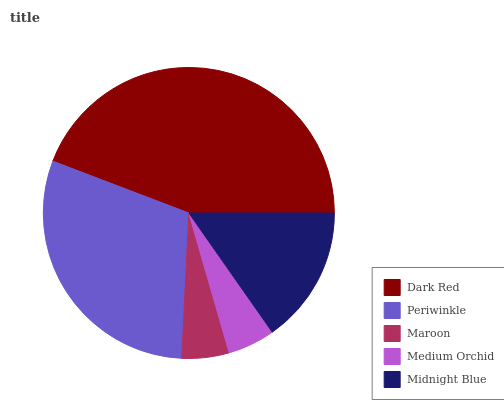Is Maroon the minimum?
Answer yes or no. Yes. Is Dark Red the maximum?
Answer yes or no. Yes. Is Periwinkle the minimum?
Answer yes or no. No. Is Periwinkle the maximum?
Answer yes or no. No. Is Dark Red greater than Periwinkle?
Answer yes or no. Yes. Is Periwinkle less than Dark Red?
Answer yes or no. Yes. Is Periwinkle greater than Dark Red?
Answer yes or no. No. Is Dark Red less than Periwinkle?
Answer yes or no. No. Is Midnight Blue the high median?
Answer yes or no. Yes. Is Midnight Blue the low median?
Answer yes or no. Yes. Is Dark Red the high median?
Answer yes or no. No. Is Maroon the low median?
Answer yes or no. No. 